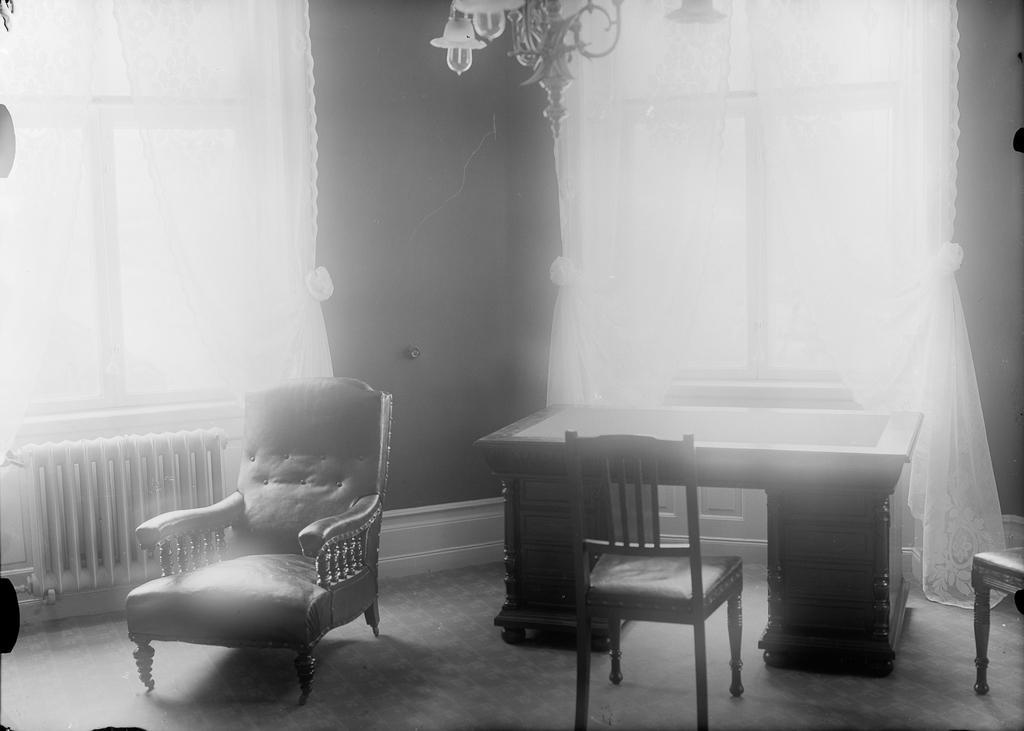Describe this image in one or two sentences. In this black and white image there is a table and chairs and there is an object near to the wall. At the top of the image there is a chandelier hanging from the ceiling. In the background there is a wall and curtains. 